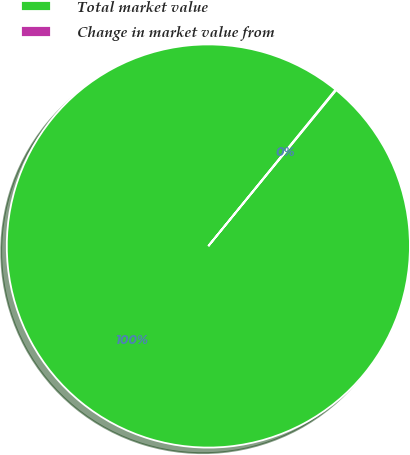<chart> <loc_0><loc_0><loc_500><loc_500><pie_chart><fcel>Total market value<fcel>Change in market value from<nl><fcel>99.94%<fcel>0.06%<nl></chart> 